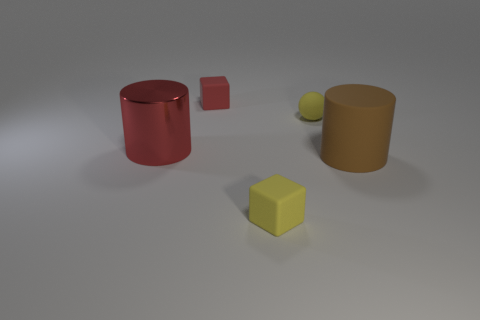The tiny red object is what shape?
Offer a very short reply. Cube. Does the large red cylinder have the same material as the ball?
Offer a terse response. No. Is the number of things behind the tiny red object the same as the number of yellow rubber spheres left of the big brown matte cylinder?
Your response must be concise. No. There is a large object that is to the left of the big matte cylinder on the right side of the tiny rubber ball; is there a tiny thing in front of it?
Make the answer very short. Yes. Do the red block and the sphere have the same size?
Ensure brevity in your answer.  Yes. There is a big matte thing that is in front of the big cylinder to the left of the red object to the right of the shiny thing; what is its color?
Your answer should be compact. Brown. What number of other small rubber balls have the same color as the small rubber sphere?
Your answer should be compact. 0. How many small things are either cyan shiny cylinders or spheres?
Make the answer very short. 1. Are there any other objects that have the same shape as the brown rubber object?
Offer a terse response. Yes. Do the red shiny thing and the tiny red rubber thing have the same shape?
Your answer should be compact. No. 